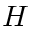<formula> <loc_0><loc_0><loc_500><loc_500>H</formula> 